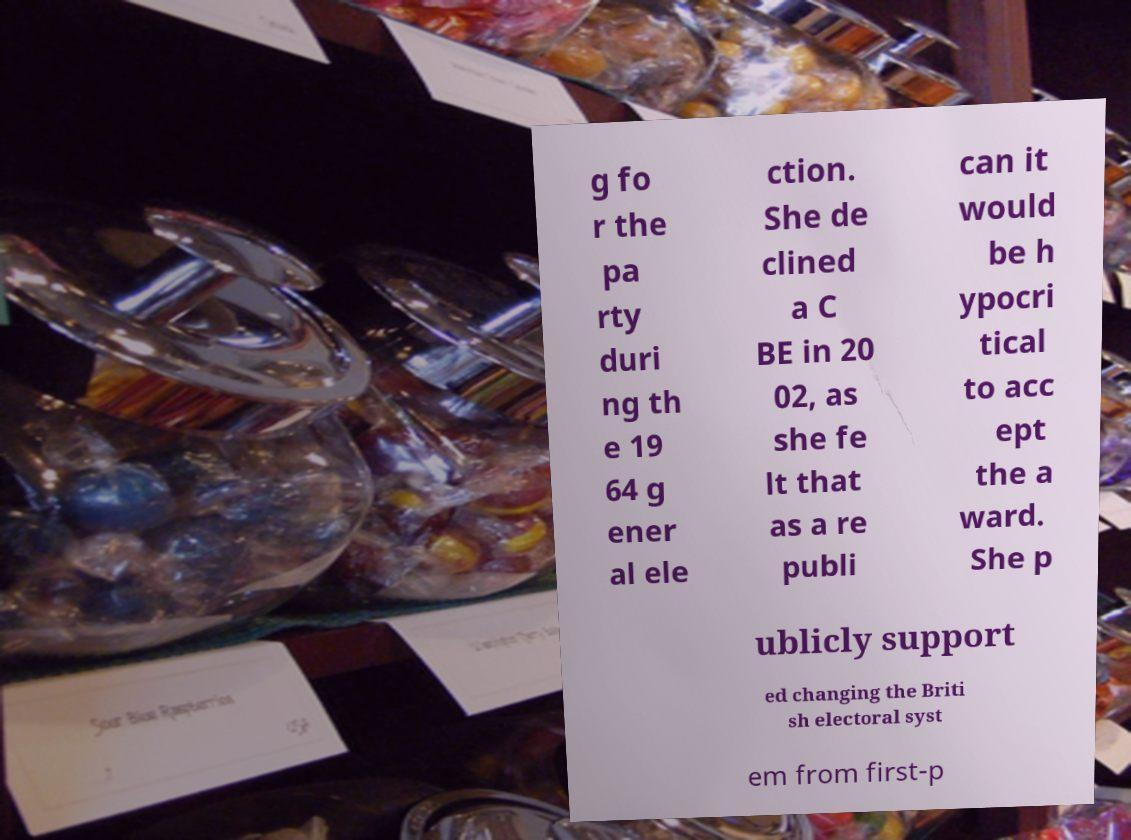Please read and relay the text visible in this image. What does it say? g fo r the pa rty duri ng th e 19 64 g ener al ele ction. She de clined a C BE in 20 02, as she fe lt that as a re publi can it would be h ypocri tical to acc ept the a ward. She p ublicly support ed changing the Briti sh electoral syst em from first-p 